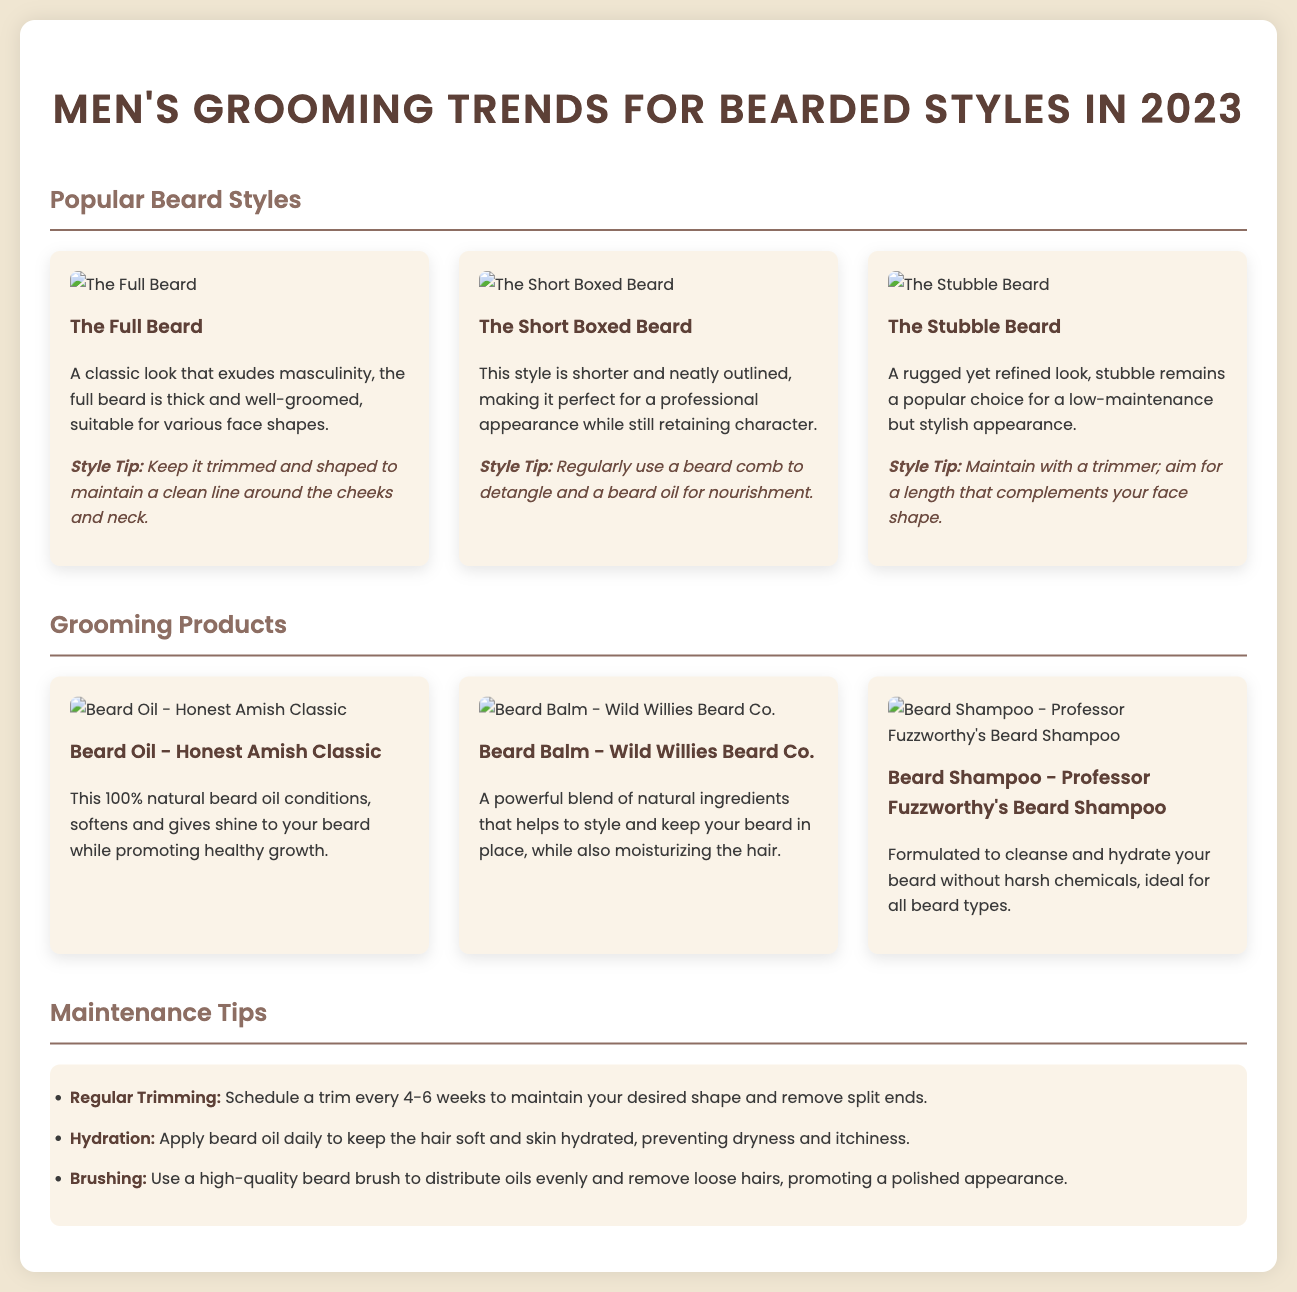What is the title of the catalog? The title is prominently displayed at the top of the document and indicates the focus of the content.
Answer: Men's Grooming Trends for Bearded Styles in 2023 How many popular beard styles are listed? The document details the beard styles presented in a grid layout, making it easy to count.
Answer: Three What type of grooming product is "Honest Amish Classic"? Referring to the section dedicated to grooming products, this product is categorized accordingly.
Answer: Beard Oil What should you apply daily for hydration? This tip is highlighted under the maintenance tips section, specifying an essential grooming product.
Answer: Beard oil What is a suggested frequency for trimming? The maintenance tips provide guidelines for upkeep, including this specific frequency.
Answer: Every 4-6 weeks Which beard style is described as "rugged yet refined"? This description corresponds to one of the styles listed in the popular beard styles section.
Answer: The Stubble Beard What is the recommended tool to keep your beard tidy? The maintenance section offers specific advice on tools for grooming, pointing towards one essential item.
Answer: Beard brush What color is the title text? The document specifies the color for the title, contributing to the catalog's visual appeal.
Answer: #5d4037 